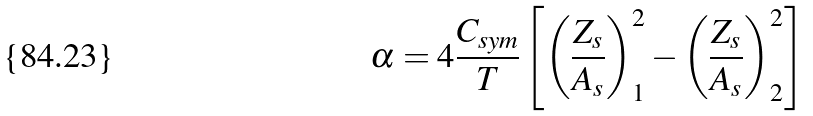Convert formula to latex. <formula><loc_0><loc_0><loc_500><loc_500>\alpha = 4 \frac { C _ { s y m } } { T } \left [ \left ( \frac { Z _ { s } } { A _ { s } } \right ) _ { 1 } ^ { 2 } - \left ( \frac { Z _ { s } } { A _ { s } } \right ) _ { 2 } ^ { 2 } \right ]</formula> 